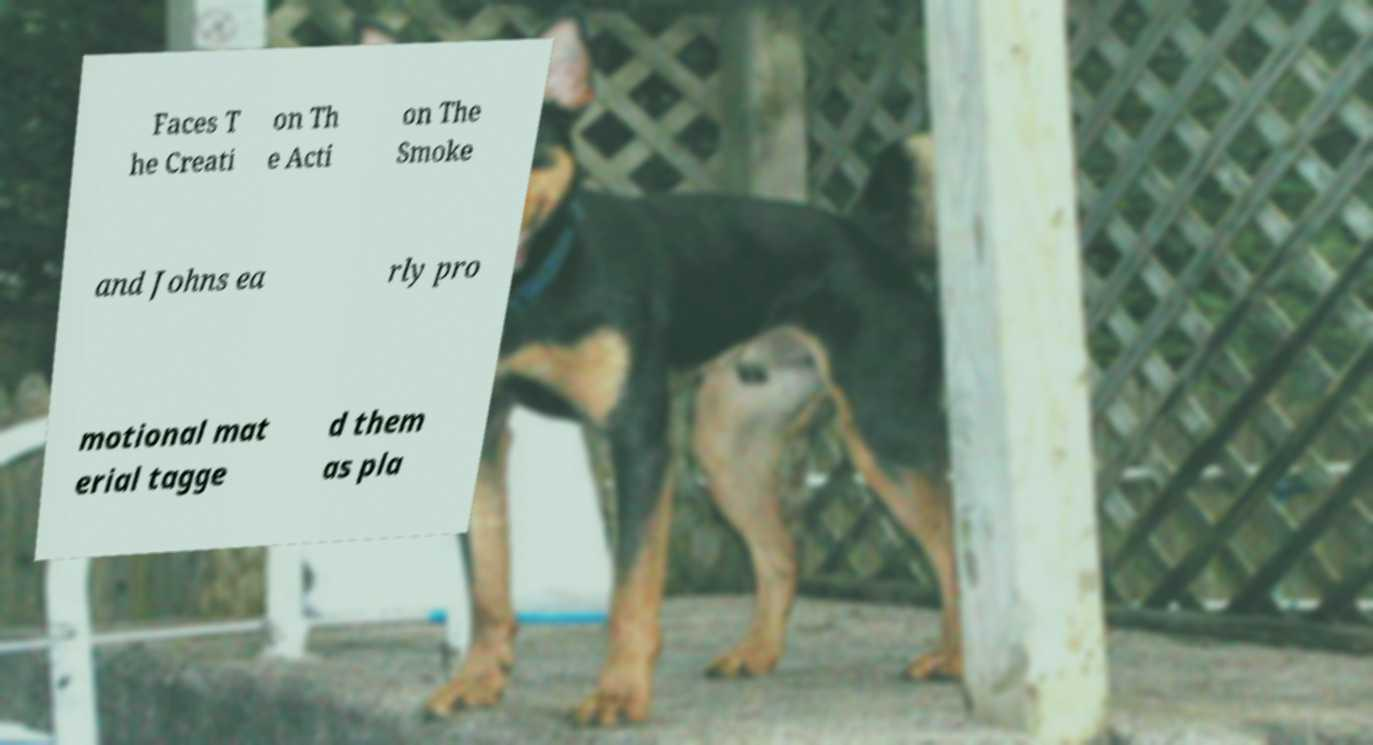What messages or text are displayed in this image? I need them in a readable, typed format. Faces T he Creati on Th e Acti on The Smoke and Johns ea rly pro motional mat erial tagge d them as pla 